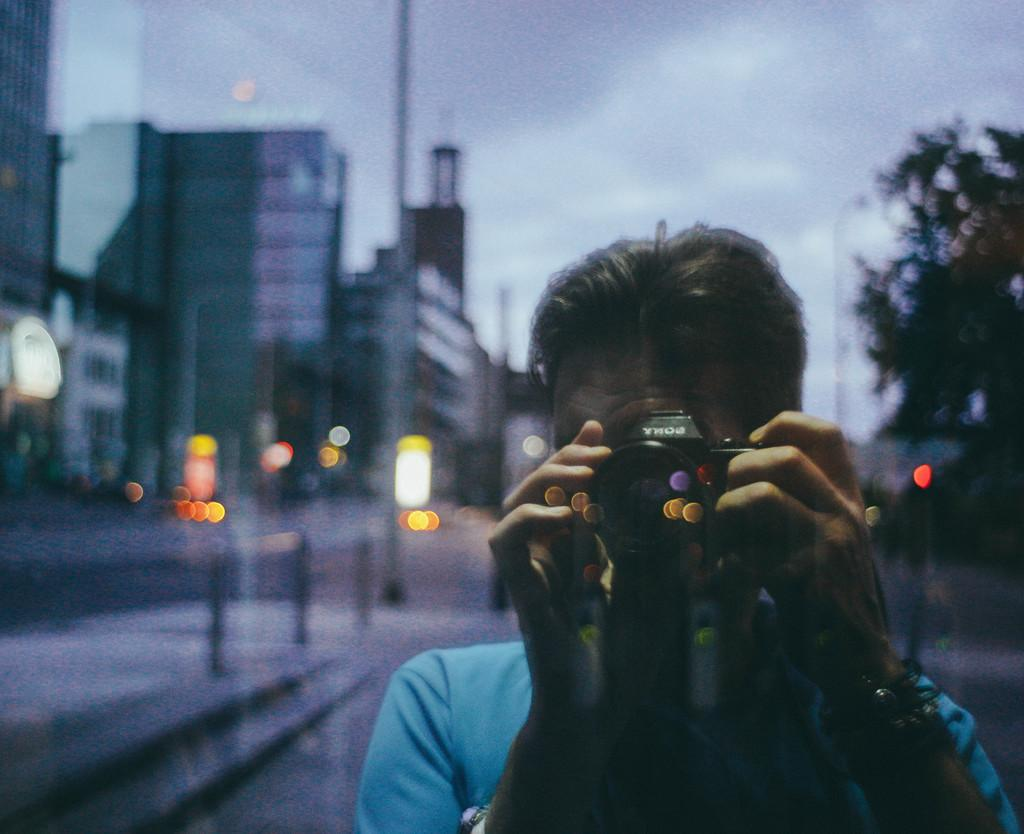What is the main subject of the image? There is a person standing in the image. What is the person holding in his hand? The person is holding a camera in his hand. Can you describe the background of the image? The background of the image is blurry. Can you hear the person laughing in the image? There is no sound in the image, so it is not possible to hear the person laughing. 